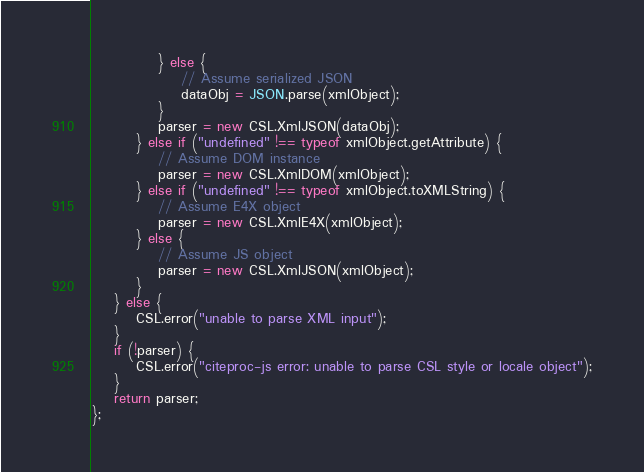<code> <loc_0><loc_0><loc_500><loc_500><_JavaScript_>            } else {
                // Assume serialized JSON
                dataObj = JSON.parse(xmlObject);
            }
            parser = new CSL.XmlJSON(dataObj);
        } else if ("undefined" !== typeof xmlObject.getAttribute) {
            // Assume DOM instance
            parser = new CSL.XmlDOM(xmlObject);
        } else if ("undefined" !== typeof xmlObject.toXMLString) {
            // Assume E4X object
            parser = new CSL.XmlE4X(xmlObject);
        } else {
            // Assume JS object
            parser = new CSL.XmlJSON(xmlObject);
        }
    } else {
        CSL.error("unable to parse XML input");
    }
    if (!parser) {
        CSL.error("citeproc-js error: unable to parse CSL style or locale object");
    }
    return parser;
};
</code> 